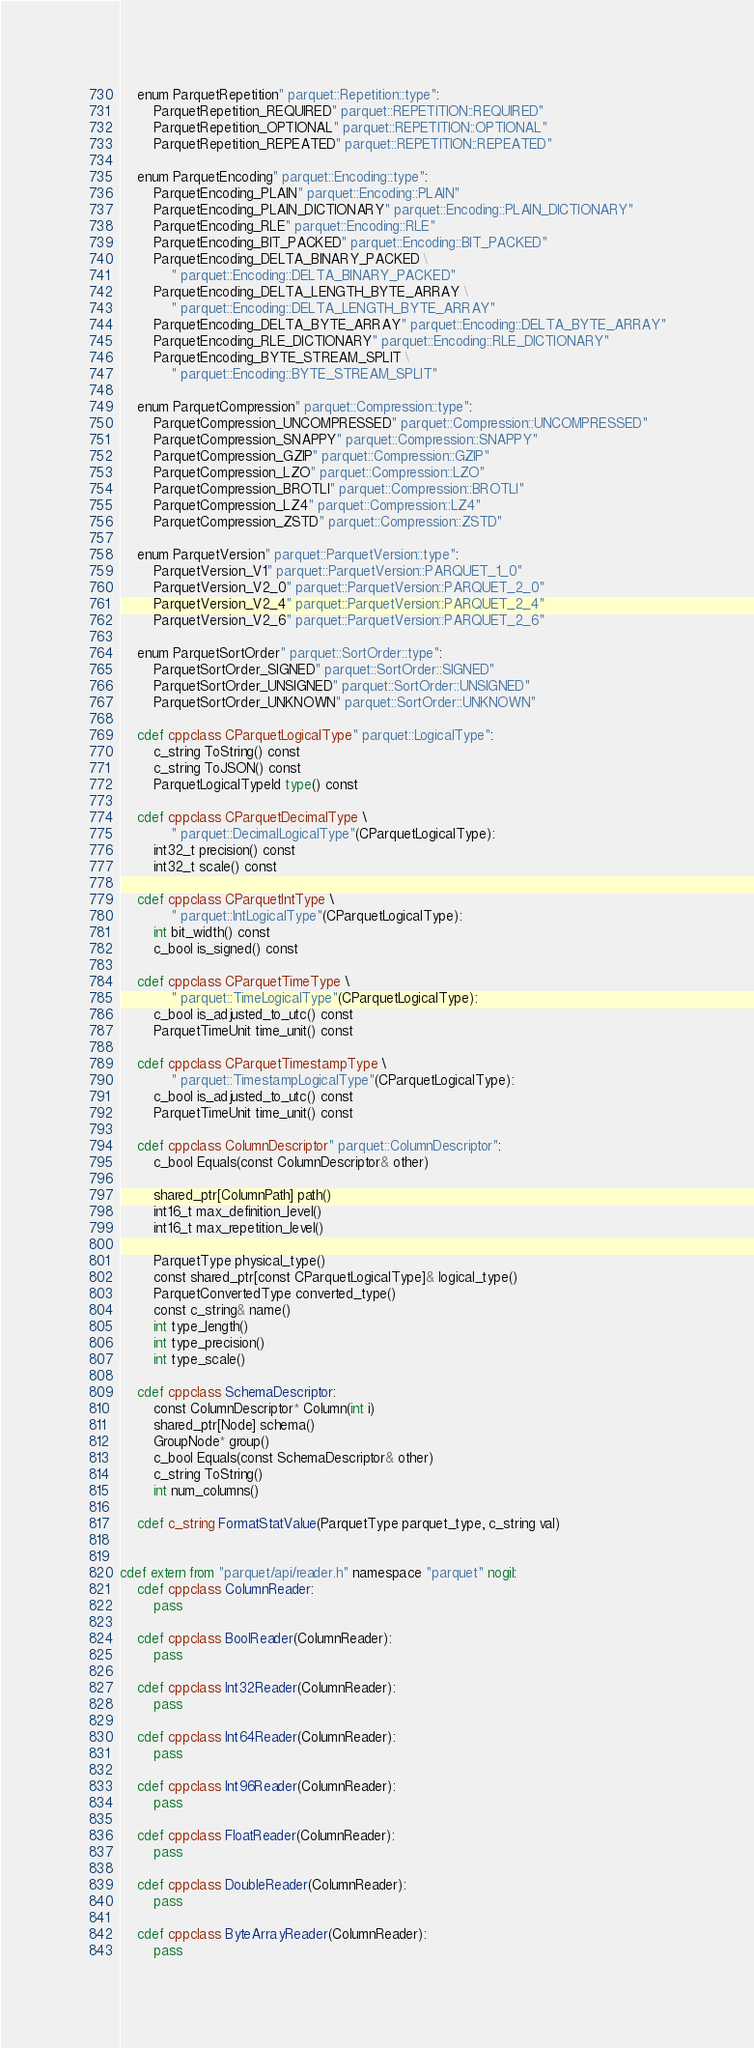Convert code to text. <code><loc_0><loc_0><loc_500><loc_500><_Cython_>    enum ParquetRepetition" parquet::Repetition::type":
        ParquetRepetition_REQUIRED" parquet::REPETITION::REQUIRED"
        ParquetRepetition_OPTIONAL" parquet::REPETITION::OPTIONAL"
        ParquetRepetition_REPEATED" parquet::REPETITION::REPEATED"

    enum ParquetEncoding" parquet::Encoding::type":
        ParquetEncoding_PLAIN" parquet::Encoding::PLAIN"
        ParquetEncoding_PLAIN_DICTIONARY" parquet::Encoding::PLAIN_DICTIONARY"
        ParquetEncoding_RLE" parquet::Encoding::RLE"
        ParquetEncoding_BIT_PACKED" parquet::Encoding::BIT_PACKED"
        ParquetEncoding_DELTA_BINARY_PACKED \
            " parquet::Encoding::DELTA_BINARY_PACKED"
        ParquetEncoding_DELTA_LENGTH_BYTE_ARRAY \
            " parquet::Encoding::DELTA_LENGTH_BYTE_ARRAY"
        ParquetEncoding_DELTA_BYTE_ARRAY" parquet::Encoding::DELTA_BYTE_ARRAY"
        ParquetEncoding_RLE_DICTIONARY" parquet::Encoding::RLE_DICTIONARY"
        ParquetEncoding_BYTE_STREAM_SPLIT \
            " parquet::Encoding::BYTE_STREAM_SPLIT"

    enum ParquetCompression" parquet::Compression::type":
        ParquetCompression_UNCOMPRESSED" parquet::Compression::UNCOMPRESSED"
        ParquetCompression_SNAPPY" parquet::Compression::SNAPPY"
        ParquetCompression_GZIP" parquet::Compression::GZIP"
        ParquetCompression_LZO" parquet::Compression::LZO"
        ParquetCompression_BROTLI" parquet::Compression::BROTLI"
        ParquetCompression_LZ4" parquet::Compression::LZ4"
        ParquetCompression_ZSTD" parquet::Compression::ZSTD"

    enum ParquetVersion" parquet::ParquetVersion::type":
        ParquetVersion_V1" parquet::ParquetVersion::PARQUET_1_0"
        ParquetVersion_V2_0" parquet::ParquetVersion::PARQUET_2_0"
        ParquetVersion_V2_4" parquet::ParquetVersion::PARQUET_2_4"
        ParquetVersion_V2_6" parquet::ParquetVersion::PARQUET_2_6"

    enum ParquetSortOrder" parquet::SortOrder::type":
        ParquetSortOrder_SIGNED" parquet::SortOrder::SIGNED"
        ParquetSortOrder_UNSIGNED" parquet::SortOrder::UNSIGNED"
        ParquetSortOrder_UNKNOWN" parquet::SortOrder::UNKNOWN"

    cdef cppclass CParquetLogicalType" parquet::LogicalType":
        c_string ToString() const
        c_string ToJSON() const
        ParquetLogicalTypeId type() const

    cdef cppclass CParquetDecimalType \
            " parquet::DecimalLogicalType"(CParquetLogicalType):
        int32_t precision() const
        int32_t scale() const

    cdef cppclass CParquetIntType \
            " parquet::IntLogicalType"(CParquetLogicalType):
        int bit_width() const
        c_bool is_signed() const

    cdef cppclass CParquetTimeType \
            " parquet::TimeLogicalType"(CParquetLogicalType):
        c_bool is_adjusted_to_utc() const
        ParquetTimeUnit time_unit() const

    cdef cppclass CParquetTimestampType \
            " parquet::TimestampLogicalType"(CParquetLogicalType):
        c_bool is_adjusted_to_utc() const
        ParquetTimeUnit time_unit() const

    cdef cppclass ColumnDescriptor" parquet::ColumnDescriptor":
        c_bool Equals(const ColumnDescriptor& other)

        shared_ptr[ColumnPath] path()
        int16_t max_definition_level()
        int16_t max_repetition_level()

        ParquetType physical_type()
        const shared_ptr[const CParquetLogicalType]& logical_type()
        ParquetConvertedType converted_type()
        const c_string& name()
        int type_length()
        int type_precision()
        int type_scale()

    cdef cppclass SchemaDescriptor:
        const ColumnDescriptor* Column(int i)
        shared_ptr[Node] schema()
        GroupNode* group()
        c_bool Equals(const SchemaDescriptor& other)
        c_string ToString()
        int num_columns()

    cdef c_string FormatStatValue(ParquetType parquet_type, c_string val)


cdef extern from "parquet/api/reader.h" namespace "parquet" nogil:
    cdef cppclass ColumnReader:
        pass

    cdef cppclass BoolReader(ColumnReader):
        pass

    cdef cppclass Int32Reader(ColumnReader):
        pass

    cdef cppclass Int64Reader(ColumnReader):
        pass

    cdef cppclass Int96Reader(ColumnReader):
        pass

    cdef cppclass FloatReader(ColumnReader):
        pass

    cdef cppclass DoubleReader(ColumnReader):
        pass

    cdef cppclass ByteArrayReader(ColumnReader):
        pass
</code> 